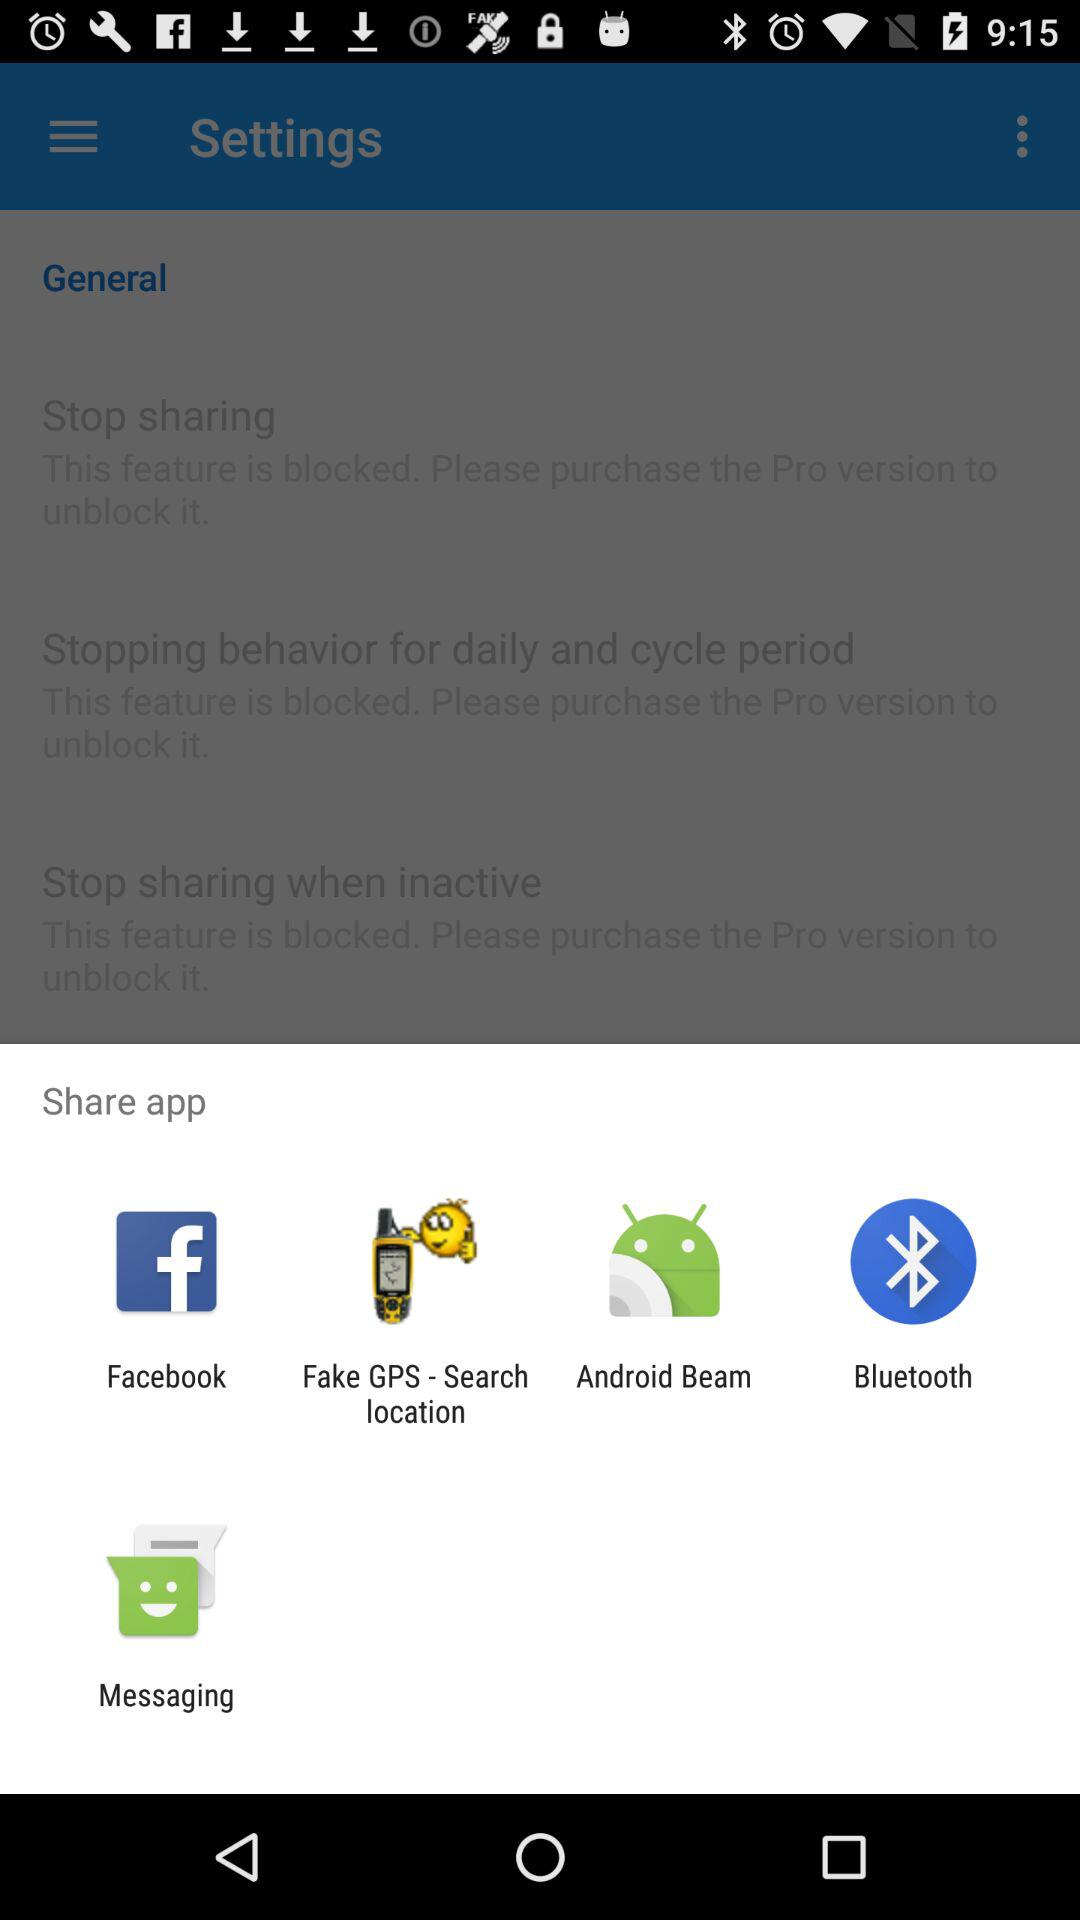How many blocked features are there that are related to stopping sharing?
Answer the question using a single word or phrase. 3 